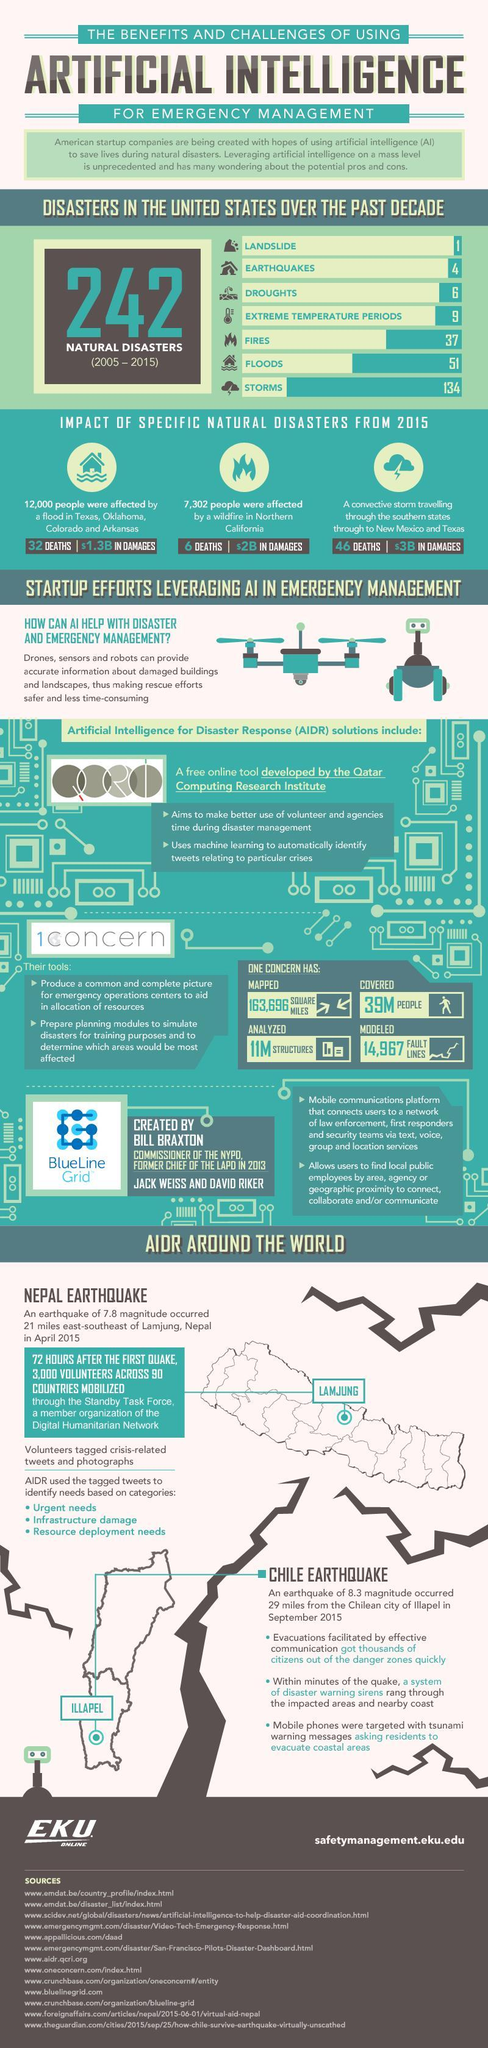What is the damage value due to floods in texas, oklahoma, colorado and arkansas
Answer the question with a short phrase. $1.3B which were the bottom 3 natural disasters in count landslide, earthquakes, droughts What is the place marked on the map of Chile Illapel How many deaths were caused due to wild fires 6 Of the natural disasters, what was the total count of floods and fires 88 What is the place marked on the map of Nepal Lamjung 